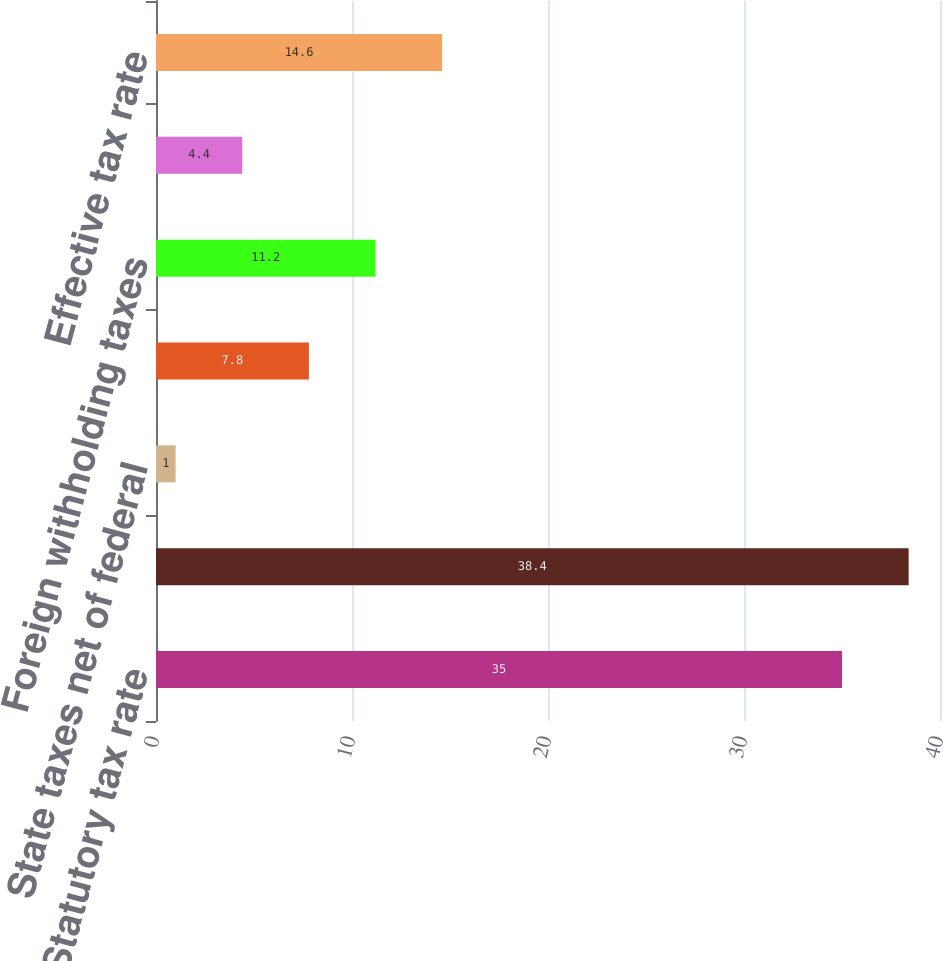<chart> <loc_0><loc_0><loc_500><loc_500><bar_chart><fcel>Statutory tax rate<fcel>Tax adjustment related to REIT<fcel>State taxes net of federal<fcel>Foreign taxes<fcel>Foreign withholding taxes<fcel>Other<fcel>Effective tax rate<nl><fcel>35<fcel>38.4<fcel>1<fcel>7.8<fcel>11.2<fcel>4.4<fcel>14.6<nl></chart> 